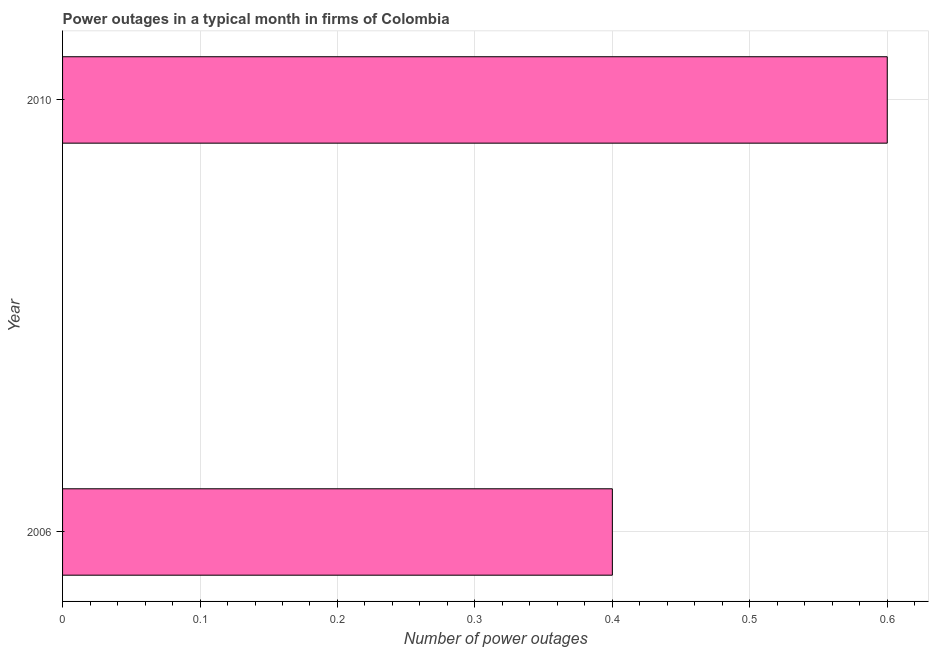Does the graph contain grids?
Offer a very short reply. Yes. What is the title of the graph?
Your answer should be very brief. Power outages in a typical month in firms of Colombia. What is the label or title of the X-axis?
Your response must be concise. Number of power outages. Across all years, what is the maximum number of power outages?
Your answer should be compact. 0.6. What is the difference between the number of power outages in 2006 and 2010?
Your response must be concise. -0.2. In how many years, is the number of power outages greater than 0.24 ?
Your response must be concise. 2. Do a majority of the years between 2006 and 2010 (inclusive) have number of power outages greater than 0.06 ?
Your answer should be compact. Yes. What is the ratio of the number of power outages in 2006 to that in 2010?
Provide a succinct answer. 0.67. Are all the bars in the graph horizontal?
Your response must be concise. Yes. What is the difference between two consecutive major ticks on the X-axis?
Your answer should be compact. 0.1. What is the Number of power outages of 2006?
Provide a succinct answer. 0.4. What is the ratio of the Number of power outages in 2006 to that in 2010?
Give a very brief answer. 0.67. 